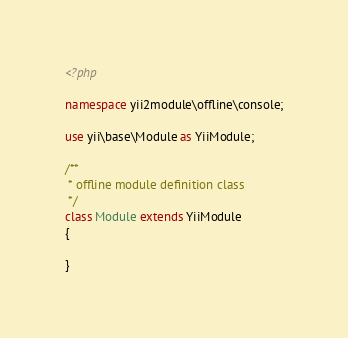<code> <loc_0><loc_0><loc_500><loc_500><_PHP_><?php

namespace yii2module\offline\console;

use yii\base\Module as YiiModule;

/**
 * offline module definition class
 */
class Module extends YiiModule
{
	
}
</code> 